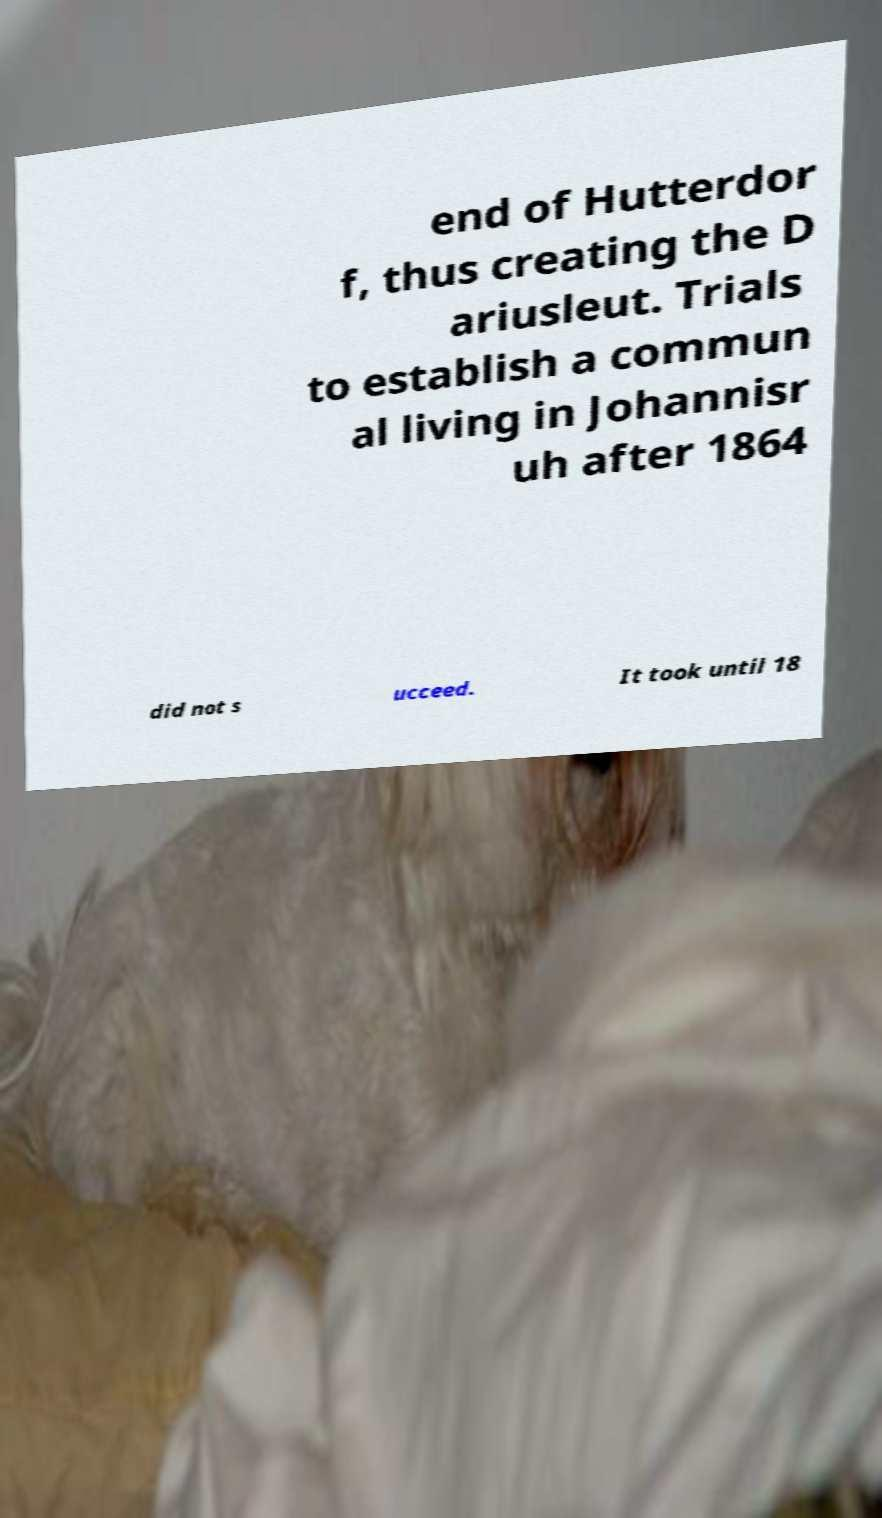I need the written content from this picture converted into text. Can you do that? end of Hutterdor f, thus creating the D ariusleut. Trials to establish a commun al living in Johannisr uh after 1864 did not s ucceed. It took until 18 